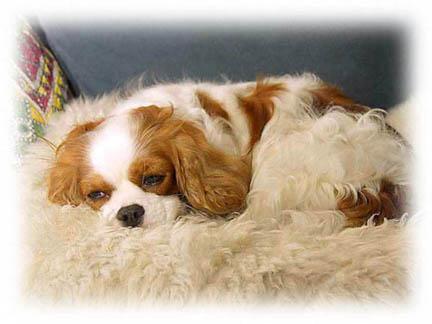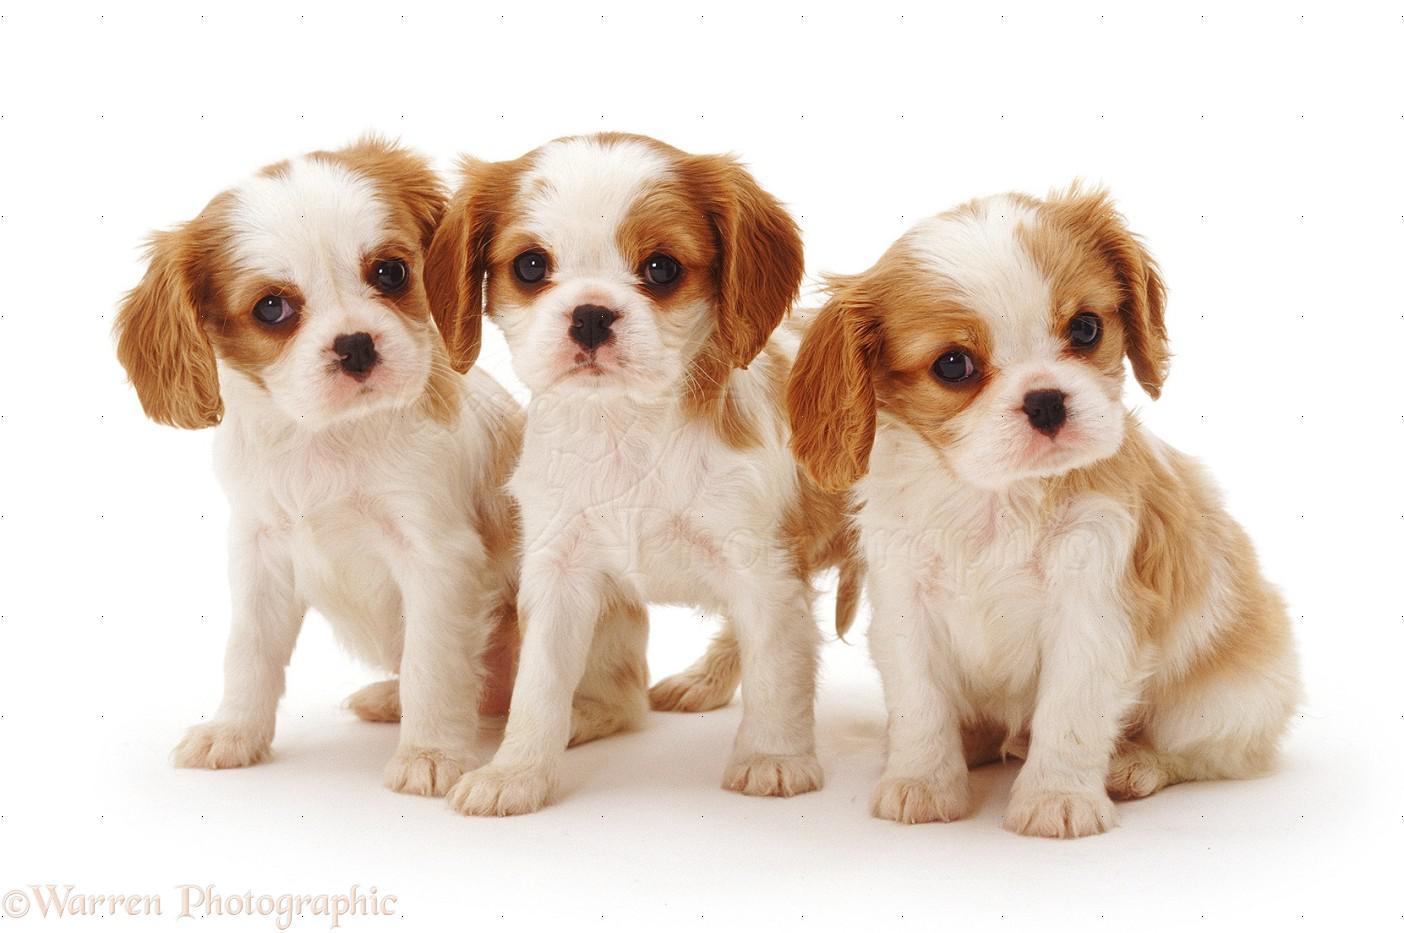The first image is the image on the left, the second image is the image on the right. For the images displayed, is the sentence "The left image has no more than one dog laying down." factually correct? Answer yes or no. Yes. The first image is the image on the left, the second image is the image on the right. Considering the images on both sides, is "In one of the image there are puppies near an adult dog." valid? Answer yes or no. No. 